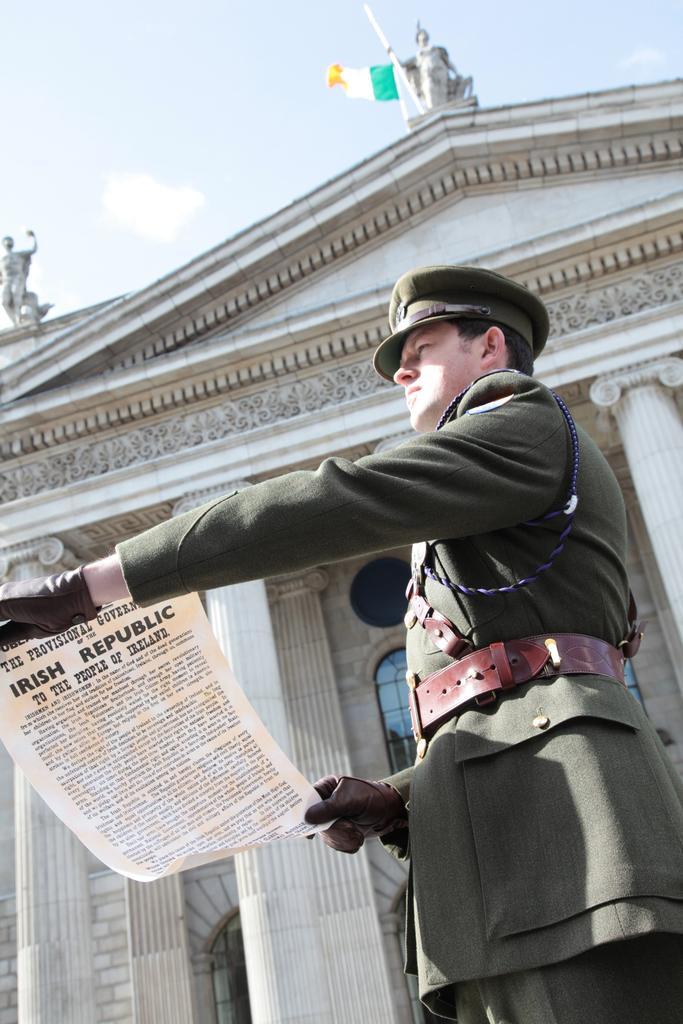How would you summarize this image in a sentence or two? In this picture we can see a man standing and holding a paper, he wore a cap, in the background there is a building, we can see a flag here, there is the sky at the top of the picture. 